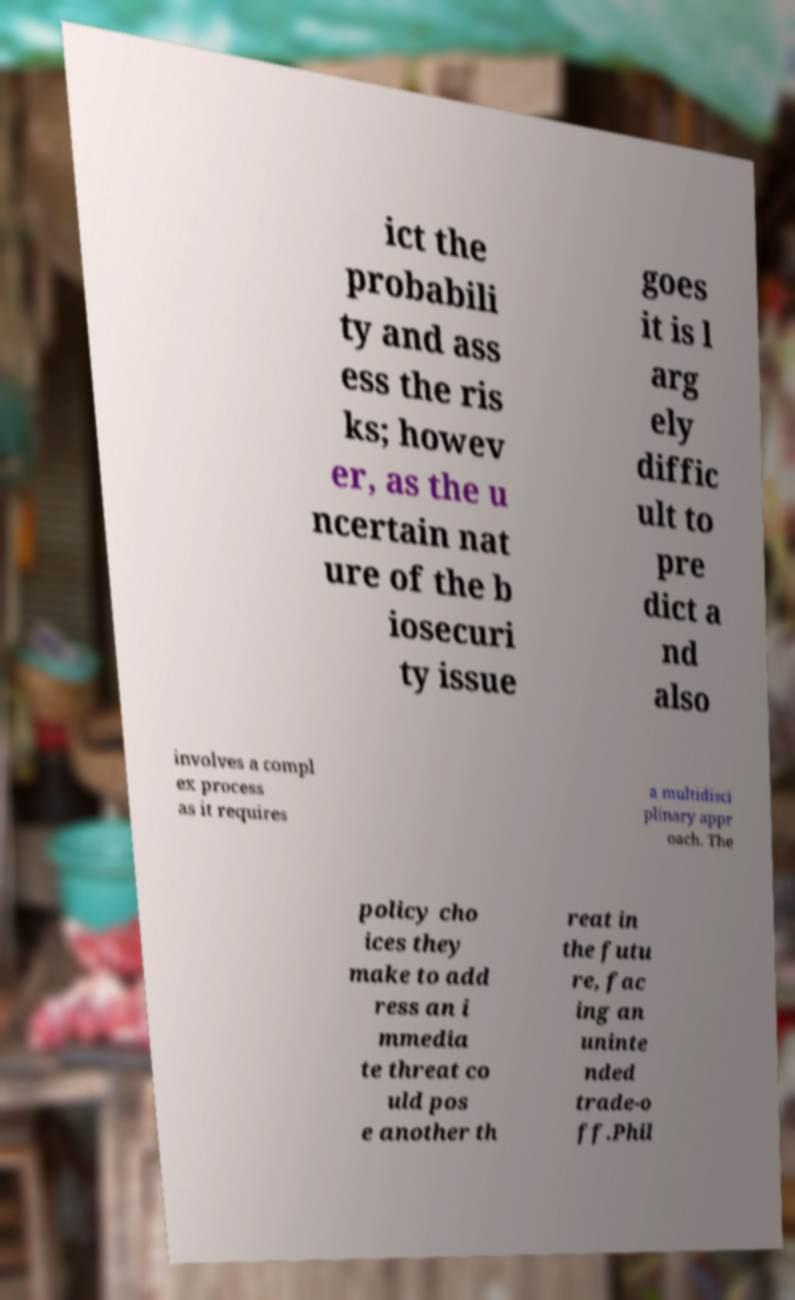Please read and relay the text visible in this image. What does it say? ict the probabili ty and ass ess the ris ks; howev er, as the u ncertain nat ure of the b iosecuri ty issue goes it is l arg ely diffic ult to pre dict a nd also involves a compl ex process as it requires a multidisci plinary appr oach. The policy cho ices they make to add ress an i mmedia te threat co uld pos e another th reat in the futu re, fac ing an uninte nded trade-o ff.Phil 